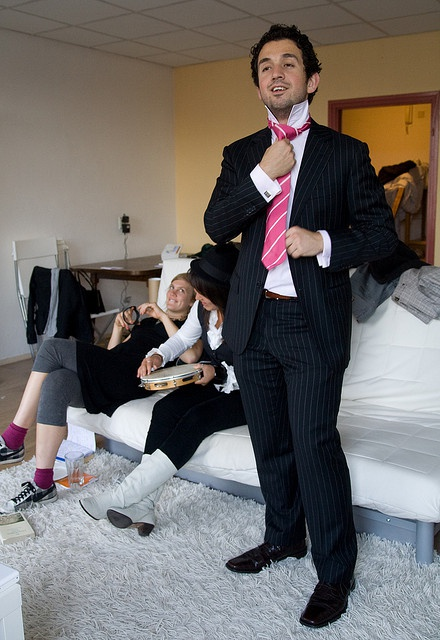Describe the objects in this image and their specific colors. I can see people in gray, black, lavender, and darkgray tones, couch in gray, lightgray, and darkgray tones, people in gray, black, lightgray, and darkgray tones, people in gray, black, tan, and darkgray tones, and chair in gray, darkgray, and lightgray tones in this image. 